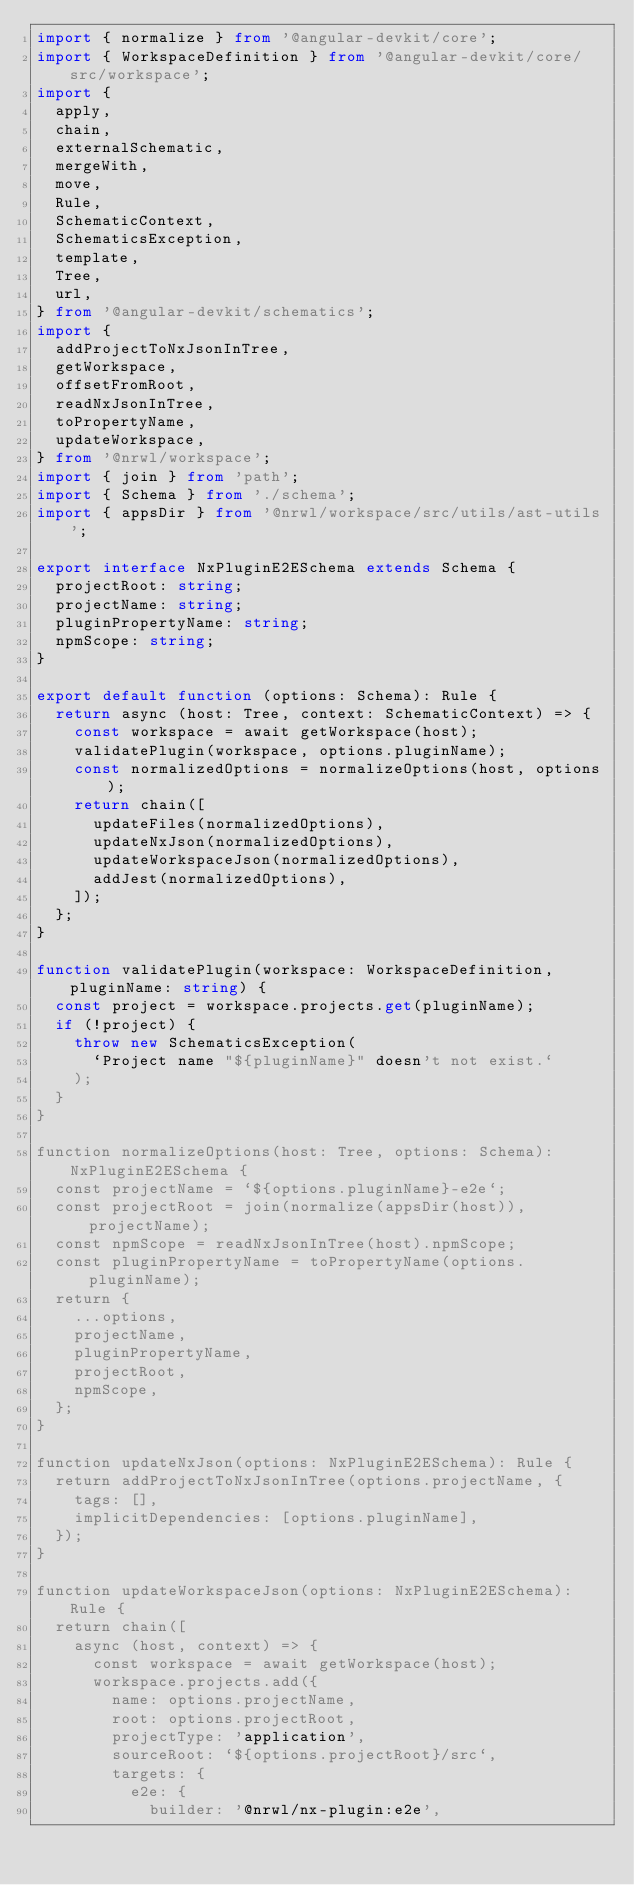Convert code to text. <code><loc_0><loc_0><loc_500><loc_500><_TypeScript_>import { normalize } from '@angular-devkit/core';
import { WorkspaceDefinition } from '@angular-devkit/core/src/workspace';
import {
  apply,
  chain,
  externalSchematic,
  mergeWith,
  move,
  Rule,
  SchematicContext,
  SchematicsException,
  template,
  Tree,
  url,
} from '@angular-devkit/schematics';
import {
  addProjectToNxJsonInTree,
  getWorkspace,
  offsetFromRoot,
  readNxJsonInTree,
  toPropertyName,
  updateWorkspace,
} from '@nrwl/workspace';
import { join } from 'path';
import { Schema } from './schema';
import { appsDir } from '@nrwl/workspace/src/utils/ast-utils';

export interface NxPluginE2ESchema extends Schema {
  projectRoot: string;
  projectName: string;
  pluginPropertyName: string;
  npmScope: string;
}

export default function (options: Schema): Rule {
  return async (host: Tree, context: SchematicContext) => {
    const workspace = await getWorkspace(host);
    validatePlugin(workspace, options.pluginName);
    const normalizedOptions = normalizeOptions(host, options);
    return chain([
      updateFiles(normalizedOptions),
      updateNxJson(normalizedOptions),
      updateWorkspaceJson(normalizedOptions),
      addJest(normalizedOptions),
    ]);
  };
}

function validatePlugin(workspace: WorkspaceDefinition, pluginName: string) {
  const project = workspace.projects.get(pluginName);
  if (!project) {
    throw new SchematicsException(
      `Project name "${pluginName}" doesn't not exist.`
    );
  }
}

function normalizeOptions(host: Tree, options: Schema): NxPluginE2ESchema {
  const projectName = `${options.pluginName}-e2e`;
  const projectRoot = join(normalize(appsDir(host)), projectName);
  const npmScope = readNxJsonInTree(host).npmScope;
  const pluginPropertyName = toPropertyName(options.pluginName);
  return {
    ...options,
    projectName,
    pluginPropertyName,
    projectRoot,
    npmScope,
  };
}

function updateNxJson(options: NxPluginE2ESchema): Rule {
  return addProjectToNxJsonInTree(options.projectName, {
    tags: [],
    implicitDependencies: [options.pluginName],
  });
}

function updateWorkspaceJson(options: NxPluginE2ESchema): Rule {
  return chain([
    async (host, context) => {
      const workspace = await getWorkspace(host);
      workspace.projects.add({
        name: options.projectName,
        root: options.projectRoot,
        projectType: 'application',
        sourceRoot: `${options.projectRoot}/src`,
        targets: {
          e2e: {
            builder: '@nrwl/nx-plugin:e2e',</code> 